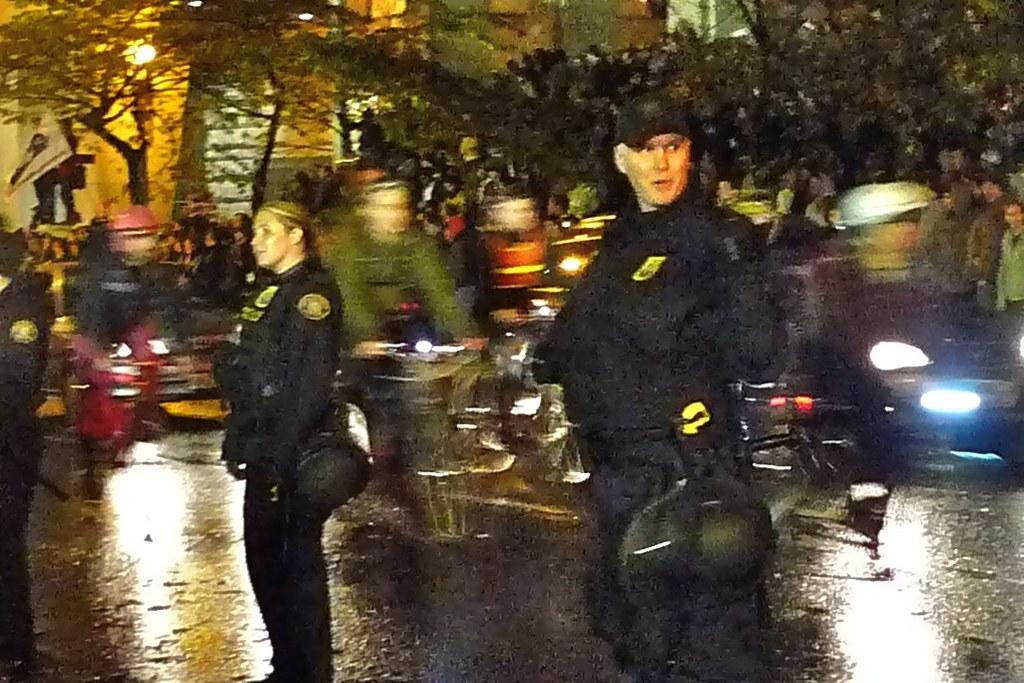How many persons are wearing black dresses in the image? There are three persons wearing black dresses in the image. What are the persons wearing black dresses doing? The three persons are standing. What can be seen behind the standing persons? There are people riding bicycles behind the standing persons. What is visible in the background of the image? There are trees and a building in the background of the image. Who is the creator of the crowd in the image? There is no crowd present in the image, so there is no creator to be identified. 